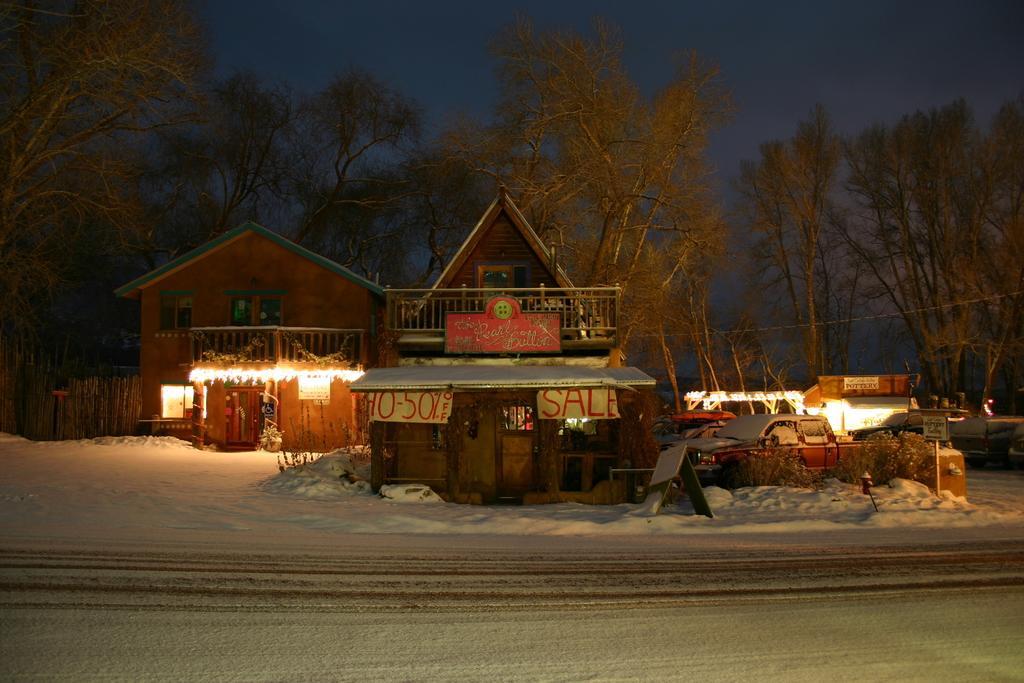Can you describe this image briefly? In this image there are two houses, few vehicles and the road covered with snow, there are few trees and the sky. 